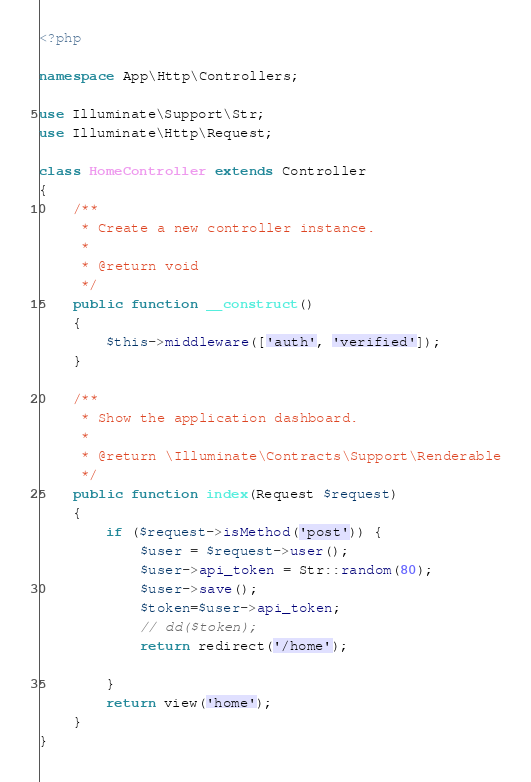Convert code to text. <code><loc_0><loc_0><loc_500><loc_500><_PHP_><?php

namespace App\Http\Controllers;

use Illuminate\Support\Str;
use Illuminate\Http\Request;

class HomeController extends Controller
{
    /**
     * Create a new controller instance.
     *
     * @return void
     */
    public function __construct()
    {
        $this->middleware(['auth', 'verified']);
    }

    /**
     * Show the application dashboard.
     *
     * @return \Illuminate\Contracts\Support\Renderable
     */
    public function index(Request $request)
    {
        if ($request->isMethod('post')) {
            $user = $request->user();
            $user->api_token = Str::random(80);
            $user->save();
            $token=$user->api_token;
            // dd($token);
            return redirect('/home');
           
        }
        return view('home');
    }
}
</code> 